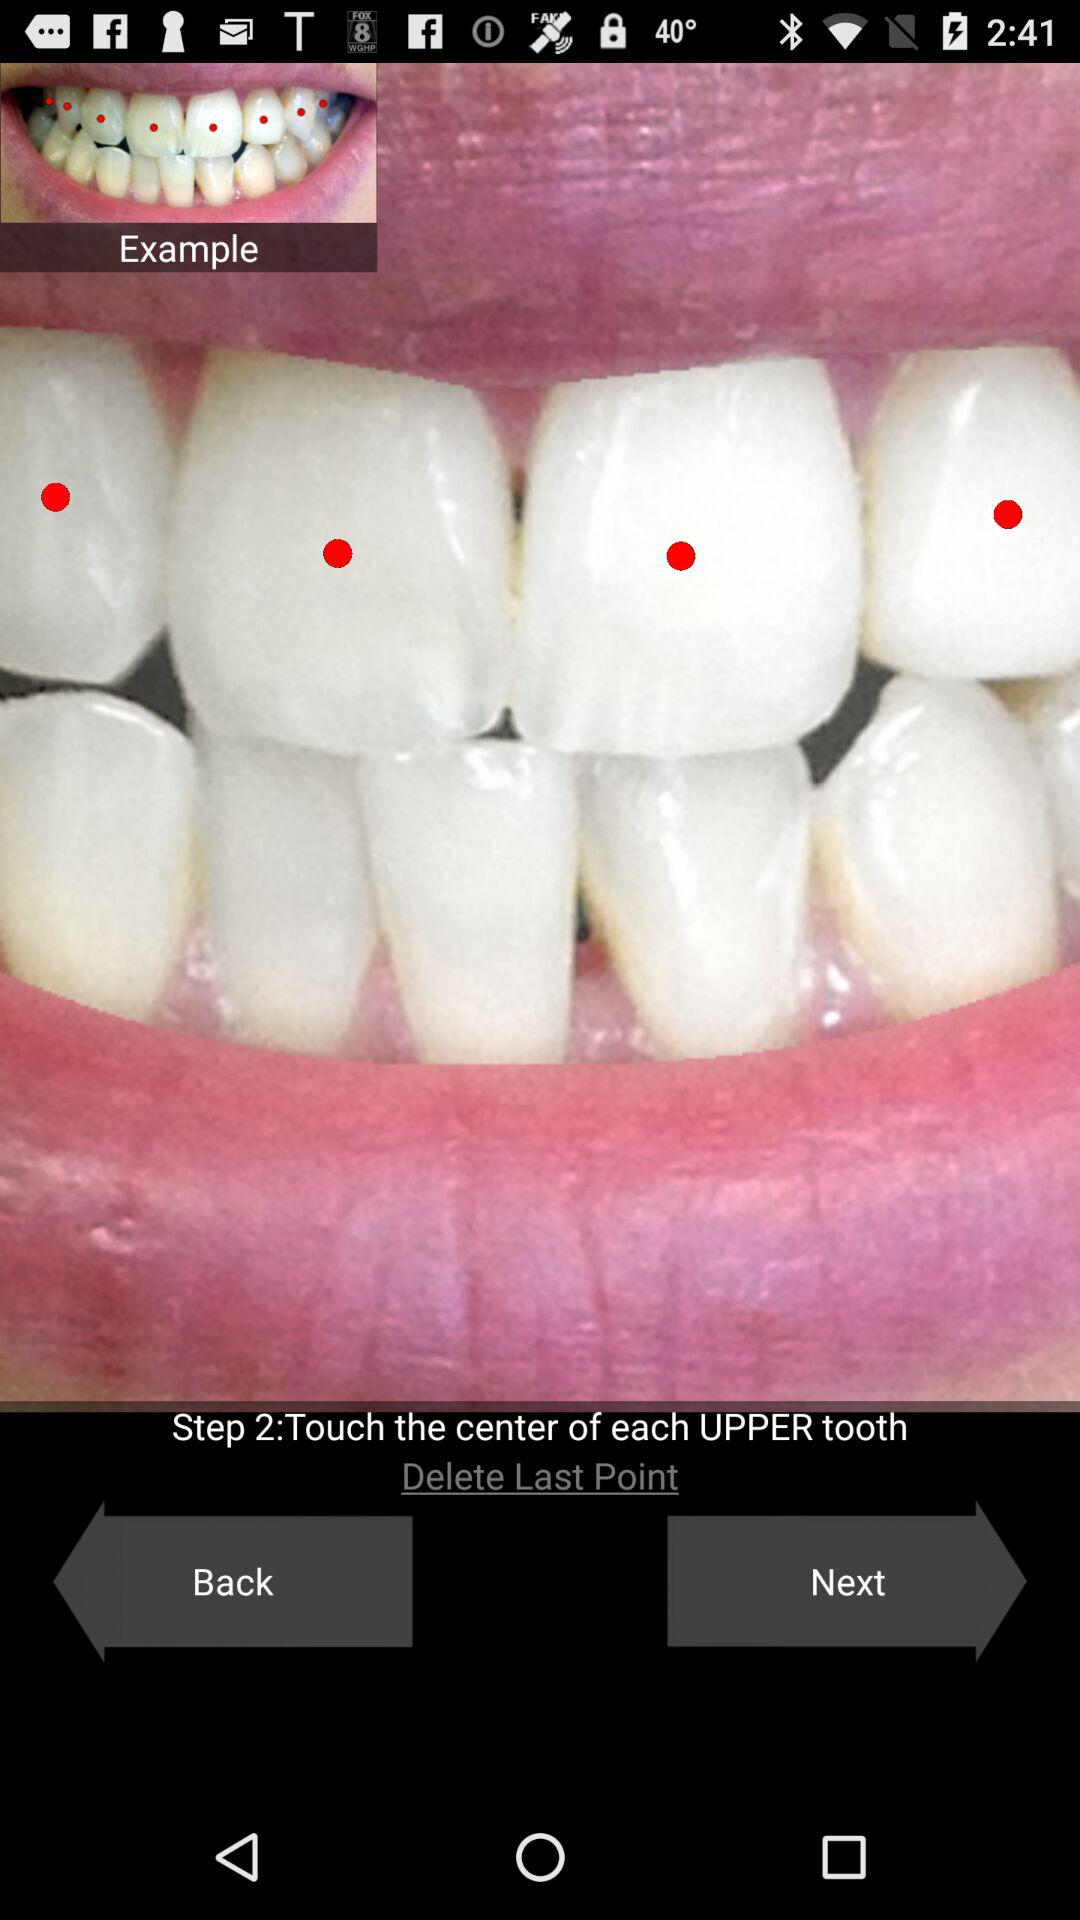How many steps are there in this process?
Answer the question using a single word or phrase. 2 